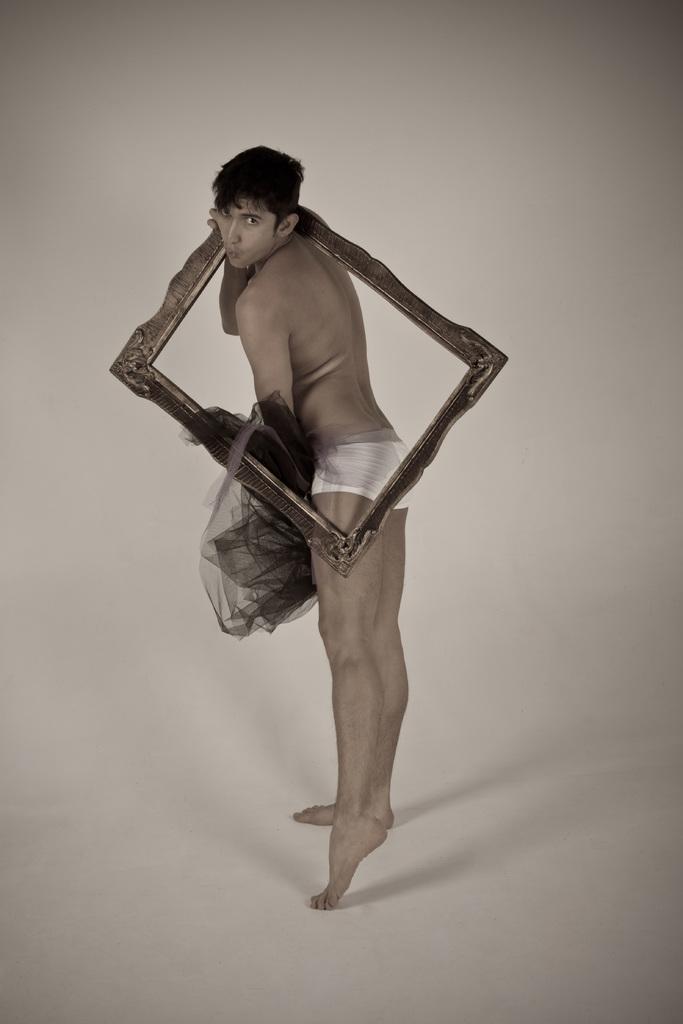Please provide a concise description of this image. In the center of the picture there is a person holding a frame and other object, he is standing on a white surface. 